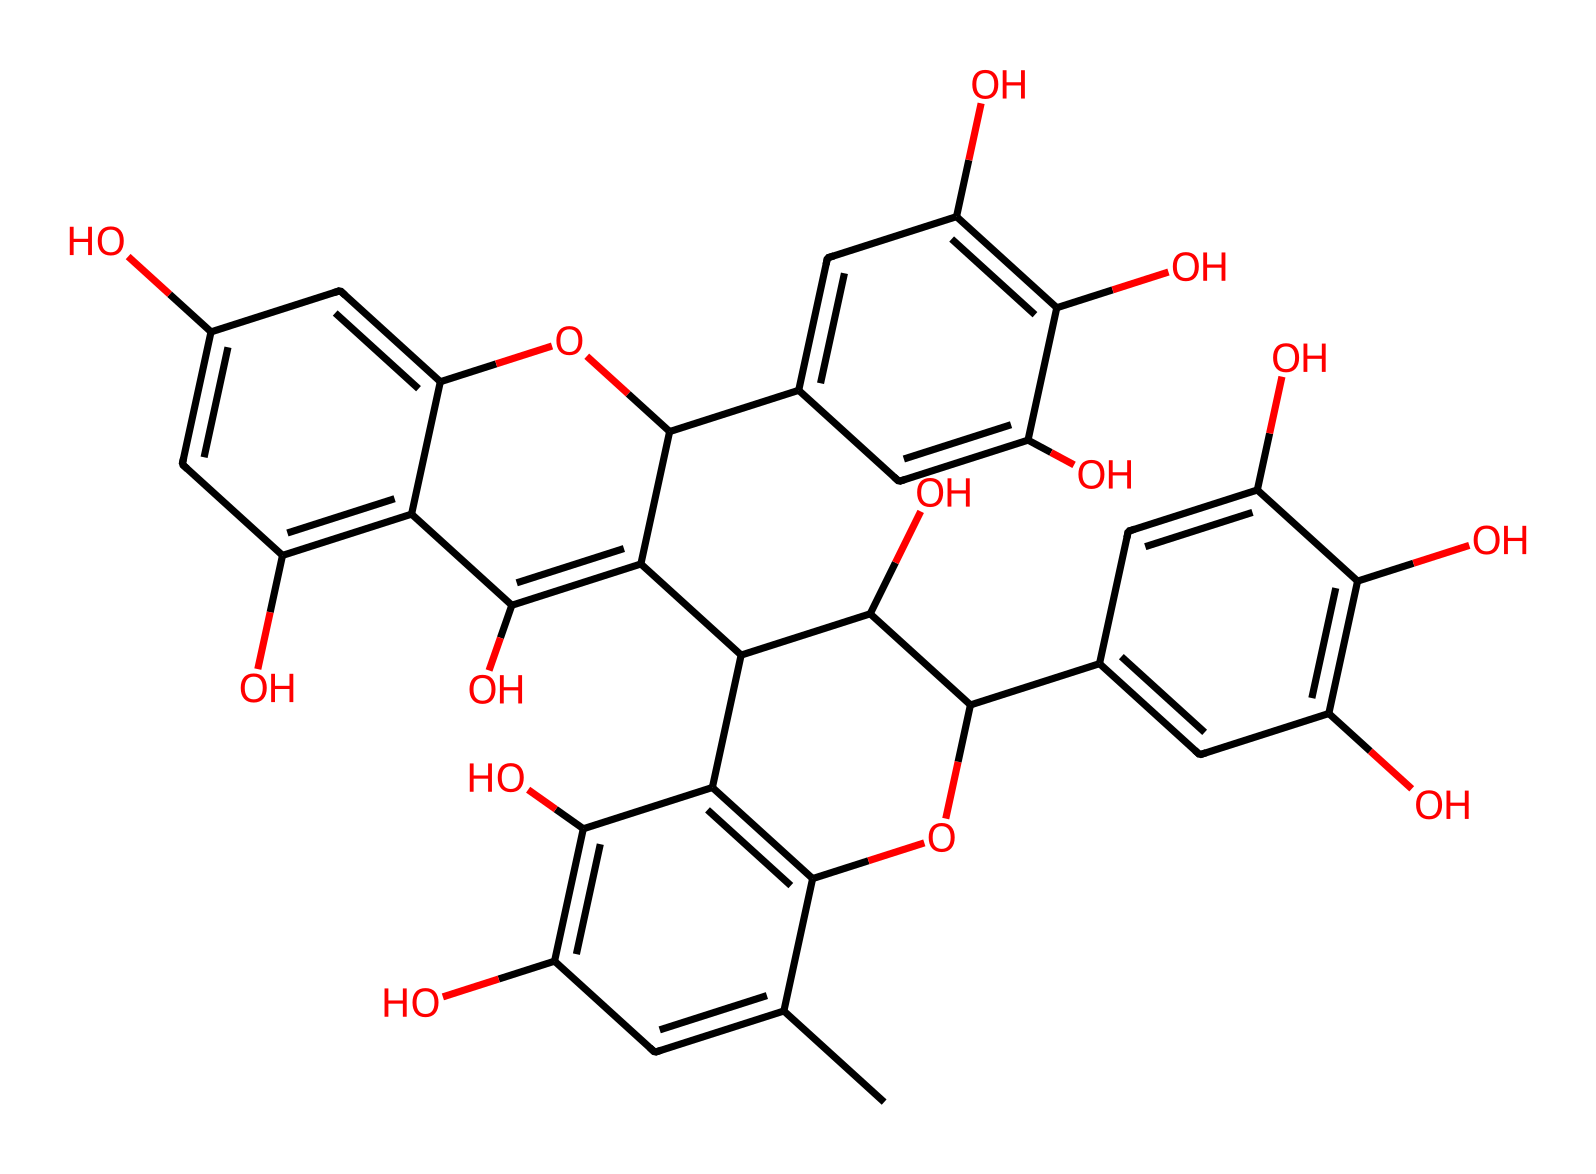What is the main functional group present in the structure? The presence of multiple hydroxyl (-OH) groups indicates that the main functional group is alcohols.
Answer: alcohols How many benzene rings are present in this molecule? After analyzing the structure, there are four distinct aromatic rings which are characteristic of tannins.
Answer: four What type of chemical compound is represented by this structure? The structure, with its multiple hydroxyl groups and aromatic rings, classifies it as a polyphenol, a type of tannin.
Answer: polyphenol Which part of the molecule contributes to its ability to bind with metal ions? The numerous hydroxyl groups in the structure provide sites for coordination with metal ions, enhancing binding properties.
Answer: hydroxyl groups What is the approximate number of carbon atoms in the chemical structure? Counting the carbons in the structure, there are a total of 30 carbon atoms throughout the polyphenolic framework.
Answer: thirty How many oxygen atoms can be found in the structure? By examining the molecule closely, we can see that there are 14 oxygen atoms present within the various functional groups.
Answer: fourteen What does the hydroxyl functional group indicate about the solubility of this compound? The presence of many hydroxyl groups suggests that the compound is likely soluble in water due to hydrogen bonding capabilities.
Answer: soluble in water 